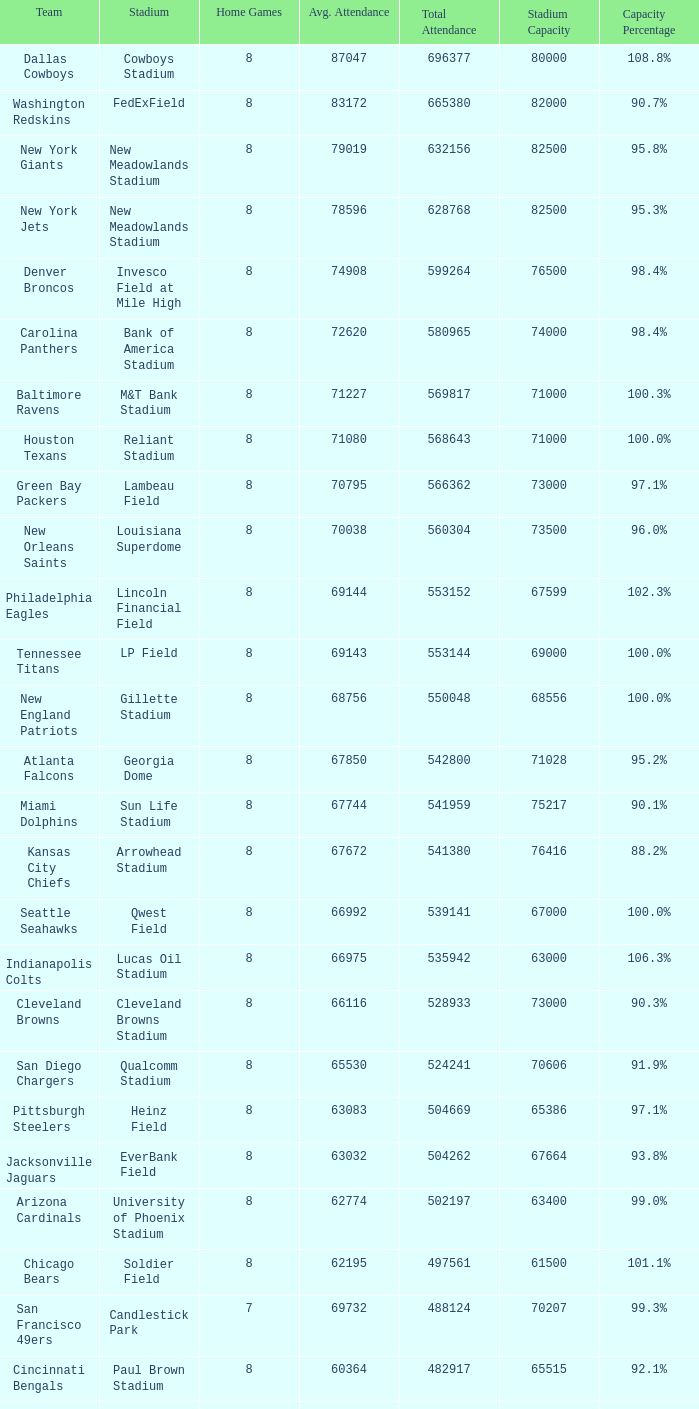What was the capacity for the Denver Broncos? 98.4%. 